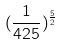Convert formula to latex. <formula><loc_0><loc_0><loc_500><loc_500>( \frac { 1 } { 4 2 5 } ) ^ { \frac { 5 } { 2 } }</formula> 